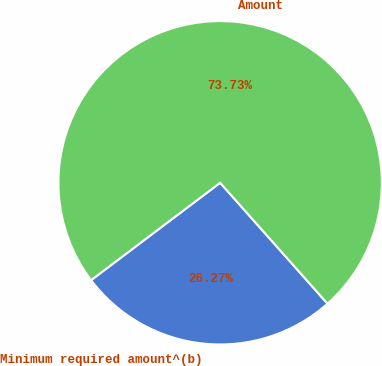Convert chart to OTSL. <chart><loc_0><loc_0><loc_500><loc_500><pie_chart><fcel>Minimum required amount^(b)<fcel>Amount<nl><fcel>26.27%<fcel>73.73%<nl></chart> 